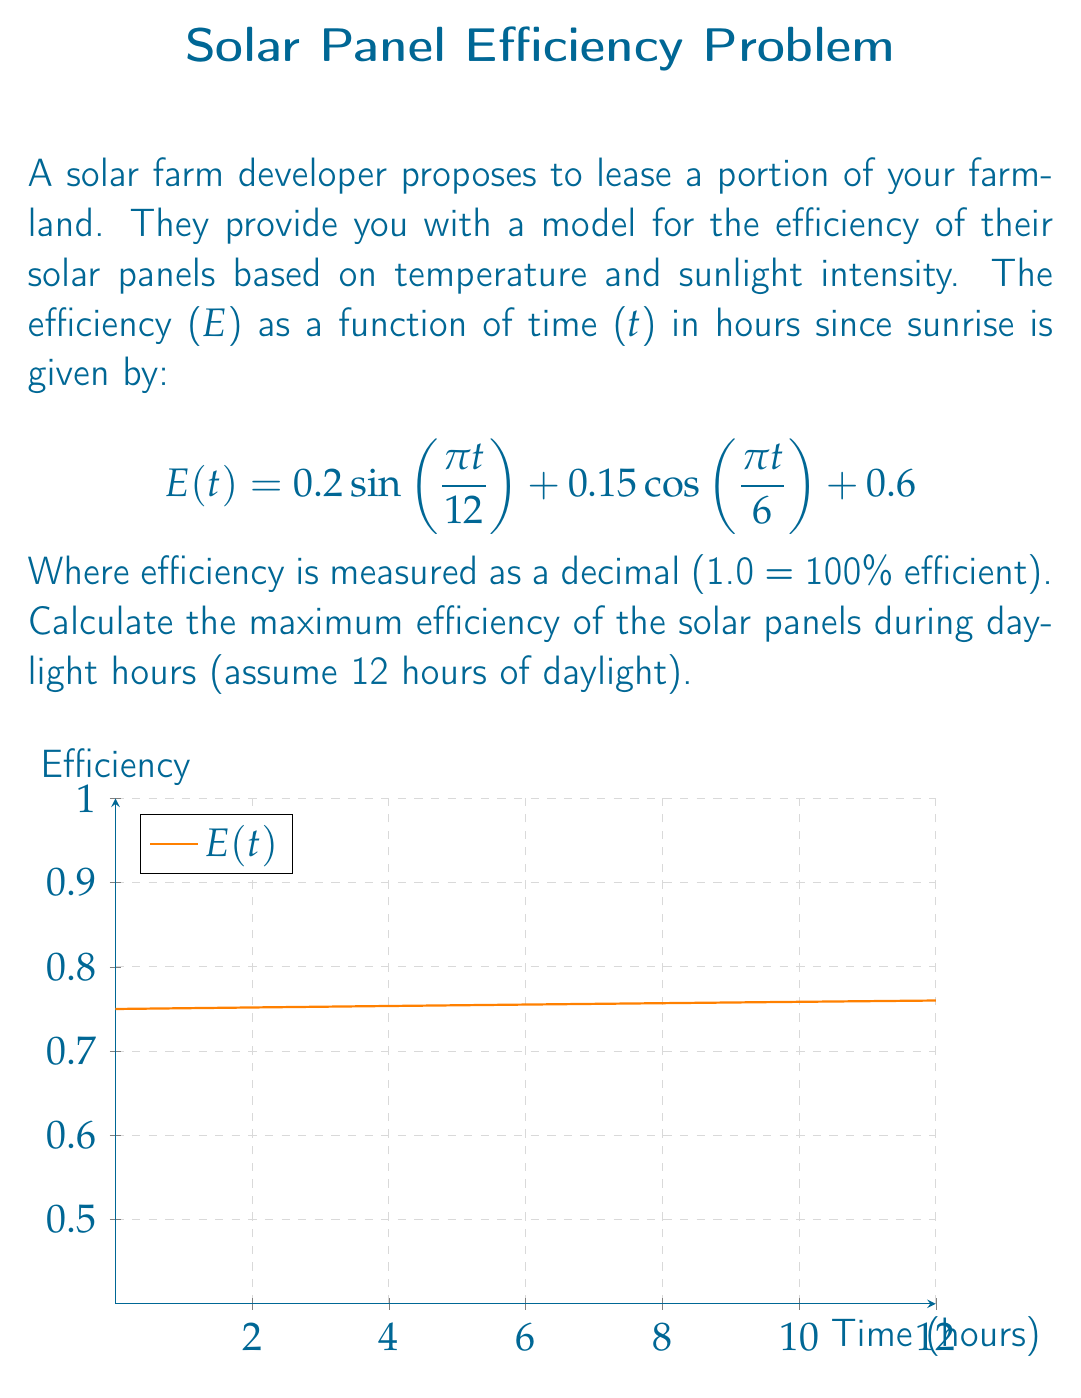Solve this math problem. To find the maximum efficiency, we need to find the maximum value of the function E(t) over the interval [0, 12]. Here's how we can approach this:

1) First, we need to find the critical points by taking the derivative of E(t) and setting it equal to zero:

   $$E'(t) = 0.2 \cdot \frac{\pi}{12} \cos(\frac{\pi t}{12}) - 0.15 \cdot \frac{\pi}{6} \sin(\frac{\pi t}{6}) = 0$$

2) This equation is complex to solve analytically. Instead, we can use numerical methods or graphing to find the maximum.

3) By observing the graph, we can see that the maximum occurs around t = 6 (midday).

4) To find the exact maximum, we can evaluate E(t) at t = 6:

   $$E(6) = 0.2 \sin(\frac{\pi \cdot 6}{12}) + 0.15 \cos(\frac{\pi \cdot 6}{6}) + 0.6$$
   
   $$= 0.2 \sin(\frac{\pi}{2}) + 0.15 \cos(\pi) + 0.6$$
   
   $$= 0.2 \cdot 1 + 0.15 \cdot (-1) + 0.6$$
   
   $$= 0.2 - 0.15 + 0.6 = 0.65$$

5) We can confirm this is the maximum by checking values slightly before and after t = 6.

Therefore, the maximum efficiency of the solar panels during daylight hours is 0.65 or 65%.
Answer: 0.65 (65% efficiency) 